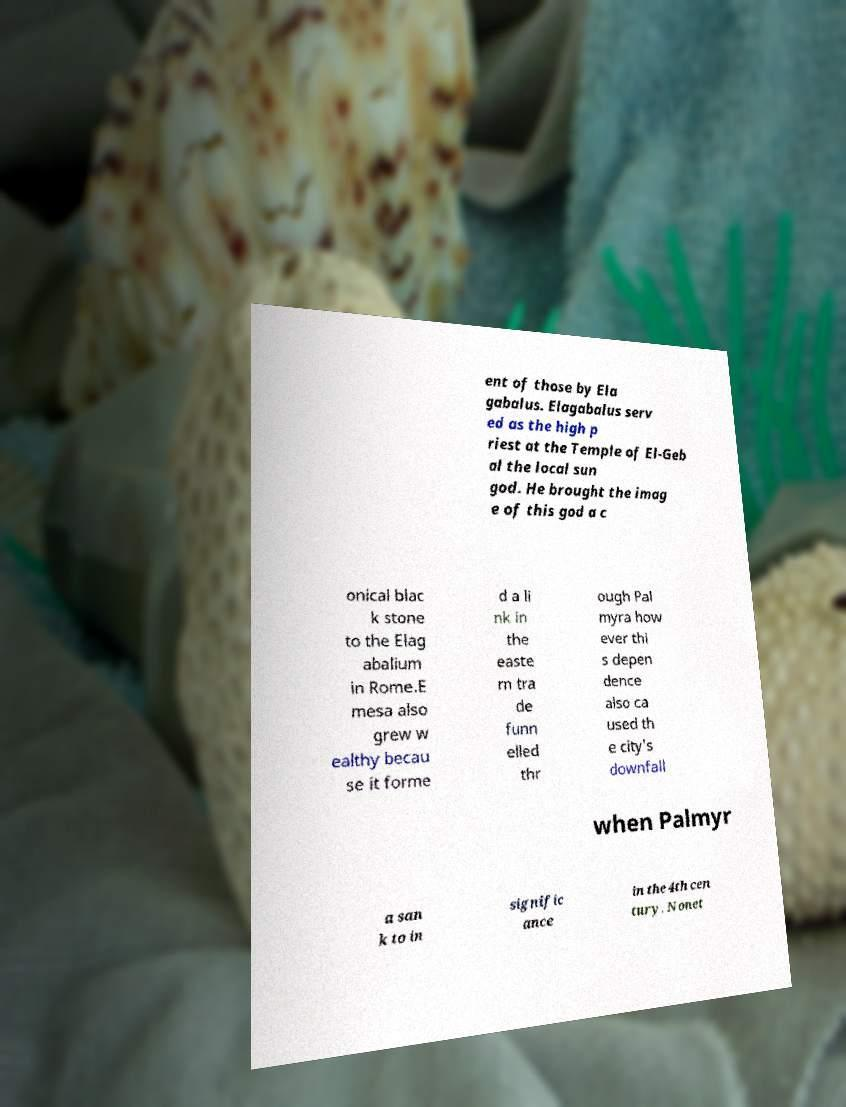Could you extract and type out the text from this image? ent of those by Ela gabalus. Elagabalus serv ed as the high p riest at the Temple of El-Geb al the local sun god. He brought the imag e of this god a c onical blac k stone to the Elag abalium in Rome.E mesa also grew w ealthy becau se it forme d a li nk in the easte rn tra de funn elled thr ough Pal myra how ever thi s depen dence also ca used th e city's downfall when Palmyr a san k to in signific ance in the 4th cen tury. Nonet 